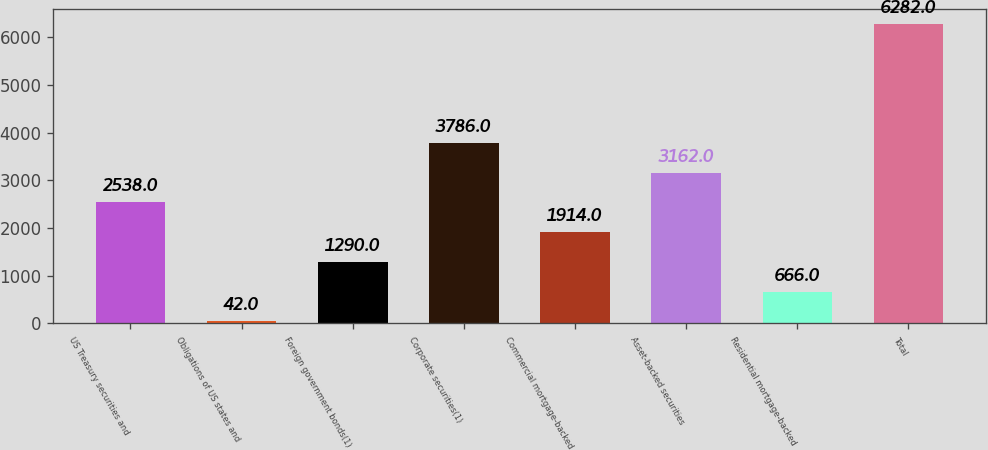Convert chart to OTSL. <chart><loc_0><loc_0><loc_500><loc_500><bar_chart><fcel>US Treasury securities and<fcel>Obligations of US states and<fcel>Foreign government bonds(1)<fcel>Corporate securities(1)<fcel>Commercial mortgage-backed<fcel>Asset-backed securities<fcel>Residential mortgage-backed<fcel>Total<nl><fcel>2538<fcel>42<fcel>1290<fcel>3786<fcel>1914<fcel>3162<fcel>666<fcel>6282<nl></chart> 